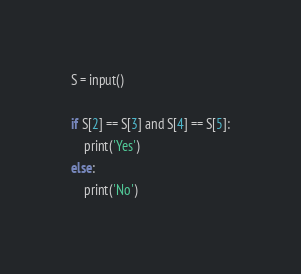Convert code to text. <code><loc_0><loc_0><loc_500><loc_500><_Python_>S = input()

if S[2] == S[3] and S[4] == S[5]:
    print('Yes')
else:
    print('No')
</code> 